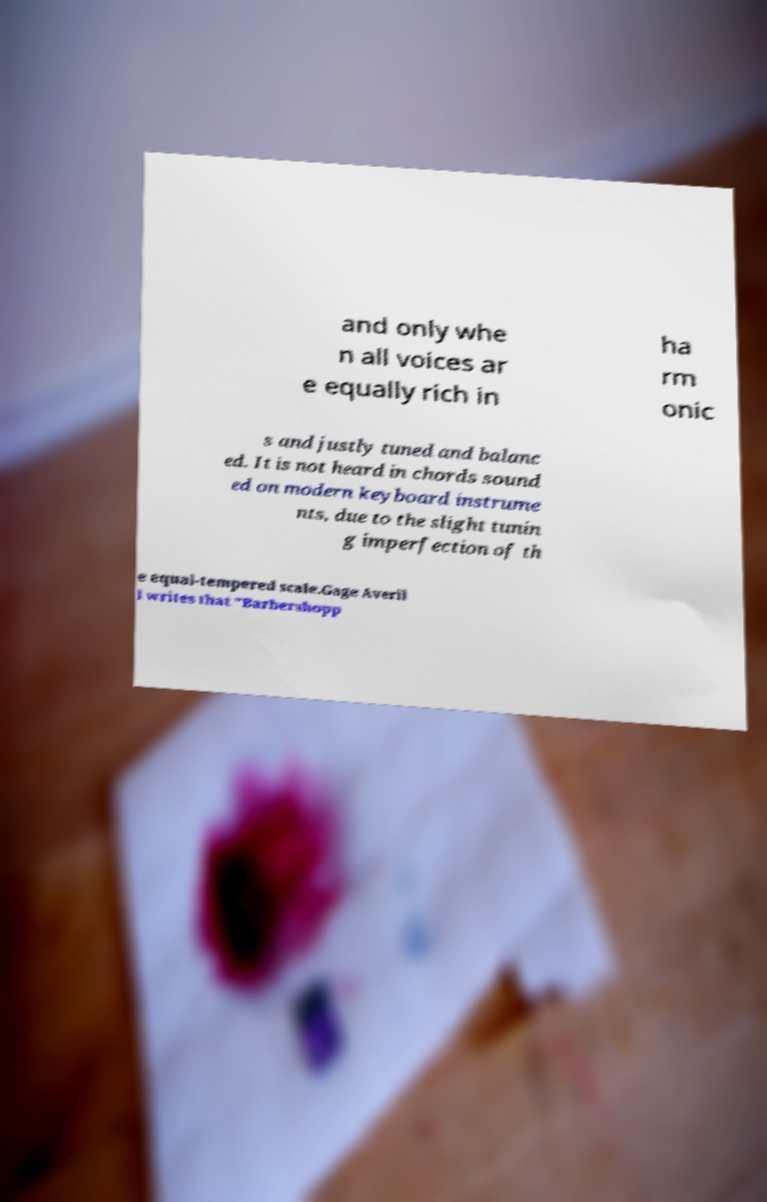Can you read and provide the text displayed in the image?This photo seems to have some interesting text. Can you extract and type it out for me? and only whe n all voices ar e equally rich in ha rm onic s and justly tuned and balanc ed. It is not heard in chords sound ed on modern keyboard instrume nts, due to the slight tunin g imperfection of th e equal-tempered scale.Gage Averil l writes that "Barbershopp 